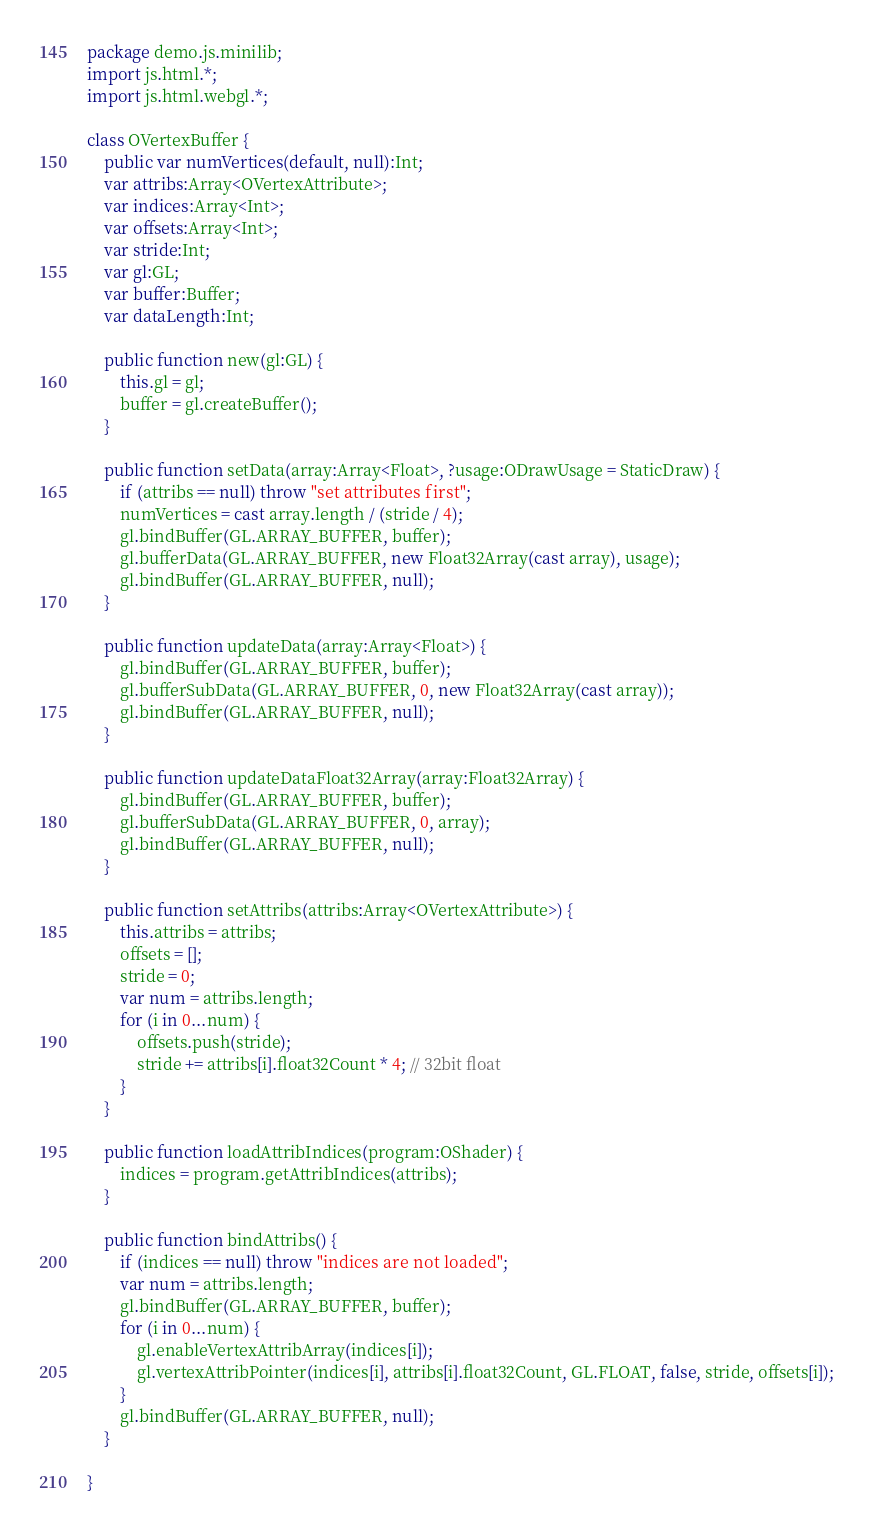Convert code to text. <code><loc_0><loc_0><loc_500><loc_500><_Haxe_>package demo.js.minilib;
import js.html.*;
import js.html.webgl.*;

class OVertexBuffer {
	public var numVertices(default, null):Int;
	var attribs:Array<OVertexAttribute>;
	var indices:Array<Int>;
	var offsets:Array<Int>;
	var stride:Int;
	var gl:GL;
	var buffer:Buffer;
	var dataLength:Int;

	public function new(gl:GL) {
		this.gl = gl;
		buffer = gl.createBuffer();
	}

	public function setData(array:Array<Float>, ?usage:ODrawUsage = StaticDraw) {
		if (attribs == null) throw "set attributes first";
		numVertices = cast array.length / (stride / 4);
		gl.bindBuffer(GL.ARRAY_BUFFER, buffer);
		gl.bufferData(GL.ARRAY_BUFFER, new Float32Array(cast array), usage);
		gl.bindBuffer(GL.ARRAY_BUFFER, null);
	}

	public function updateData(array:Array<Float>) {
		gl.bindBuffer(GL.ARRAY_BUFFER, buffer);
		gl.bufferSubData(GL.ARRAY_BUFFER, 0, new Float32Array(cast array));
		gl.bindBuffer(GL.ARRAY_BUFFER, null);
	}

	public function updateDataFloat32Array(array:Float32Array) {
		gl.bindBuffer(GL.ARRAY_BUFFER, buffer);
		gl.bufferSubData(GL.ARRAY_BUFFER, 0, array);
		gl.bindBuffer(GL.ARRAY_BUFFER, null);
	}

	public function setAttribs(attribs:Array<OVertexAttribute>) {
		this.attribs = attribs;
		offsets = [];
		stride = 0;
		var num = attribs.length;
		for (i in 0...num) {
			offsets.push(stride);
			stride += attribs[i].float32Count * 4; // 32bit float
		}
	}

	public function loadAttribIndices(program:OShader) {
		indices = program.getAttribIndices(attribs);
	}

	public function bindAttribs() {
		if (indices == null) throw "indices are not loaded";
		var num = attribs.length;
		gl.bindBuffer(GL.ARRAY_BUFFER, buffer);
		for (i in 0...num) {
			gl.enableVertexAttribArray(indices[i]);
			gl.vertexAttribPointer(indices[i], attribs[i].float32Count, GL.FLOAT, false, stride, offsets[i]);
		}
		gl.bindBuffer(GL.ARRAY_BUFFER, null);
	}

}
</code> 